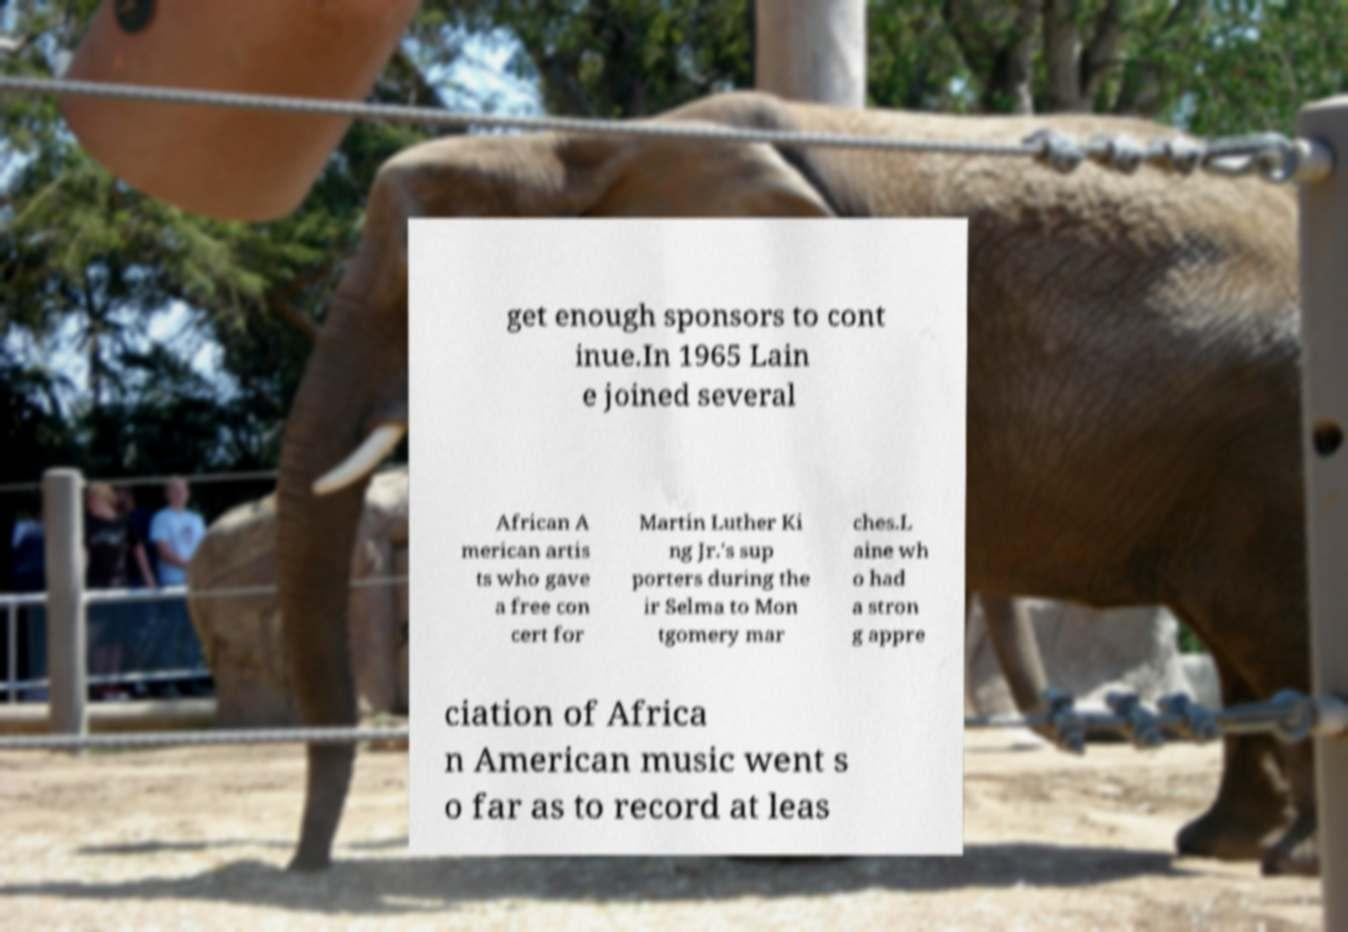I need the written content from this picture converted into text. Can you do that? get enough sponsors to cont inue.In 1965 Lain e joined several African A merican artis ts who gave a free con cert for Martin Luther Ki ng Jr.'s sup porters during the ir Selma to Mon tgomery mar ches.L aine wh o had a stron g appre ciation of Africa n American music went s o far as to record at leas 